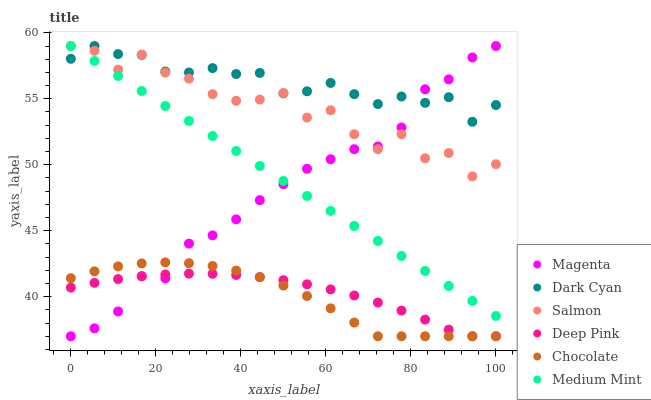Does Chocolate have the minimum area under the curve?
Answer yes or no. Yes. Does Dark Cyan have the maximum area under the curve?
Answer yes or no. Yes. Does Deep Pink have the minimum area under the curve?
Answer yes or no. No. Does Deep Pink have the maximum area under the curve?
Answer yes or no. No. Is Medium Mint the smoothest?
Answer yes or no. Yes. Is Salmon the roughest?
Answer yes or no. Yes. Is Deep Pink the smoothest?
Answer yes or no. No. Is Deep Pink the roughest?
Answer yes or no. No. Does Deep Pink have the lowest value?
Answer yes or no. Yes. Does Salmon have the lowest value?
Answer yes or no. No. Does Magenta have the highest value?
Answer yes or no. Yes. Does Deep Pink have the highest value?
Answer yes or no. No. Is Deep Pink less than Medium Mint?
Answer yes or no. Yes. Is Salmon greater than Chocolate?
Answer yes or no. Yes. Does Magenta intersect Medium Mint?
Answer yes or no. Yes. Is Magenta less than Medium Mint?
Answer yes or no. No. Is Magenta greater than Medium Mint?
Answer yes or no. No. Does Deep Pink intersect Medium Mint?
Answer yes or no. No. 